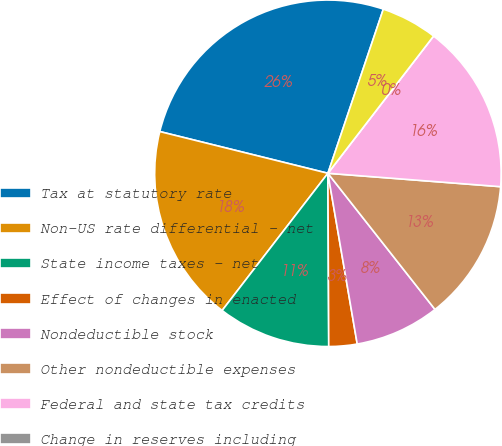Convert chart to OTSL. <chart><loc_0><loc_0><loc_500><loc_500><pie_chart><fcel>Tax at statutory rate<fcel>Non-US rate differential - net<fcel>State income taxes - net<fcel>Effect of changes in enacted<fcel>Nondeductible stock<fcel>Other nondeductible expenses<fcel>Federal and state tax credits<fcel>Change in reserves including<fcel>Other - net<nl><fcel>26.31%<fcel>18.42%<fcel>10.53%<fcel>2.63%<fcel>7.9%<fcel>13.16%<fcel>15.79%<fcel>0.0%<fcel>5.26%<nl></chart> 